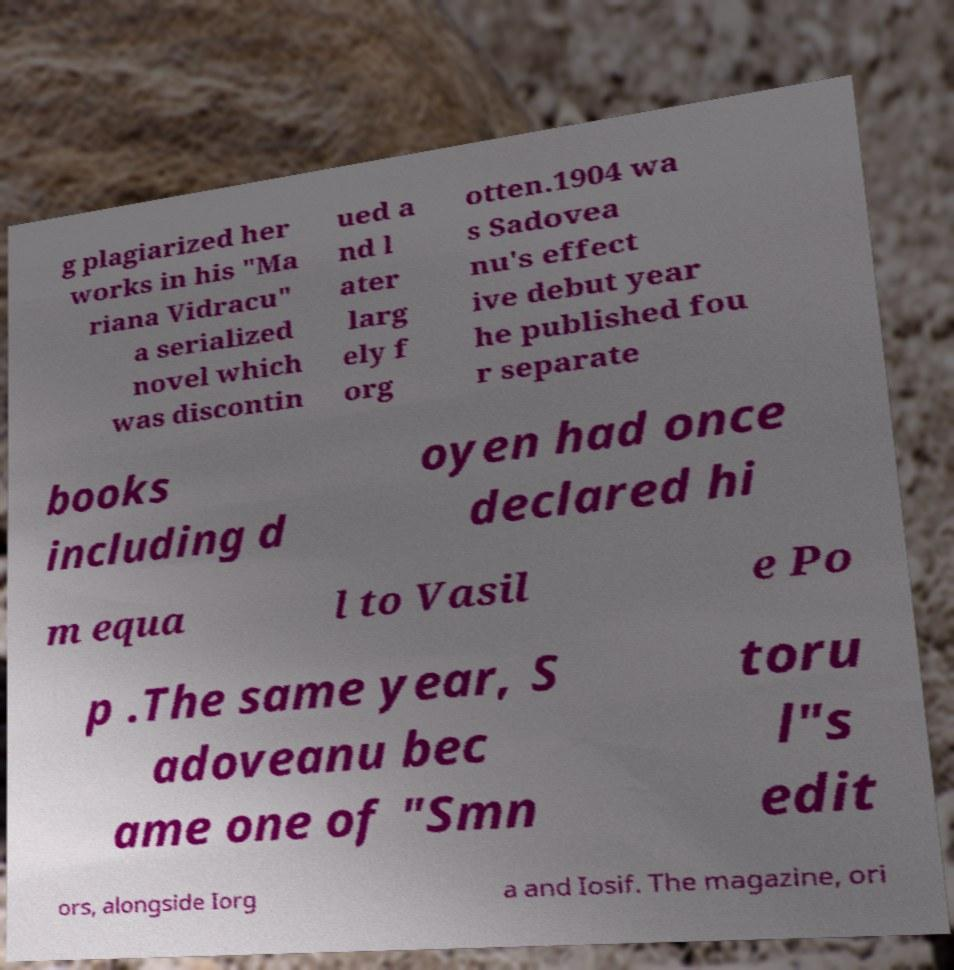Could you extract and type out the text from this image? g plagiarized her works in his "Ma riana Vidracu" a serialized novel which was discontin ued a nd l ater larg ely f org otten.1904 wa s Sadovea nu's effect ive debut year he published fou r separate books including d oyen had once declared hi m equa l to Vasil e Po p .The same year, S adoveanu bec ame one of "Smn toru l"s edit ors, alongside Iorg a and Iosif. The magazine, ori 